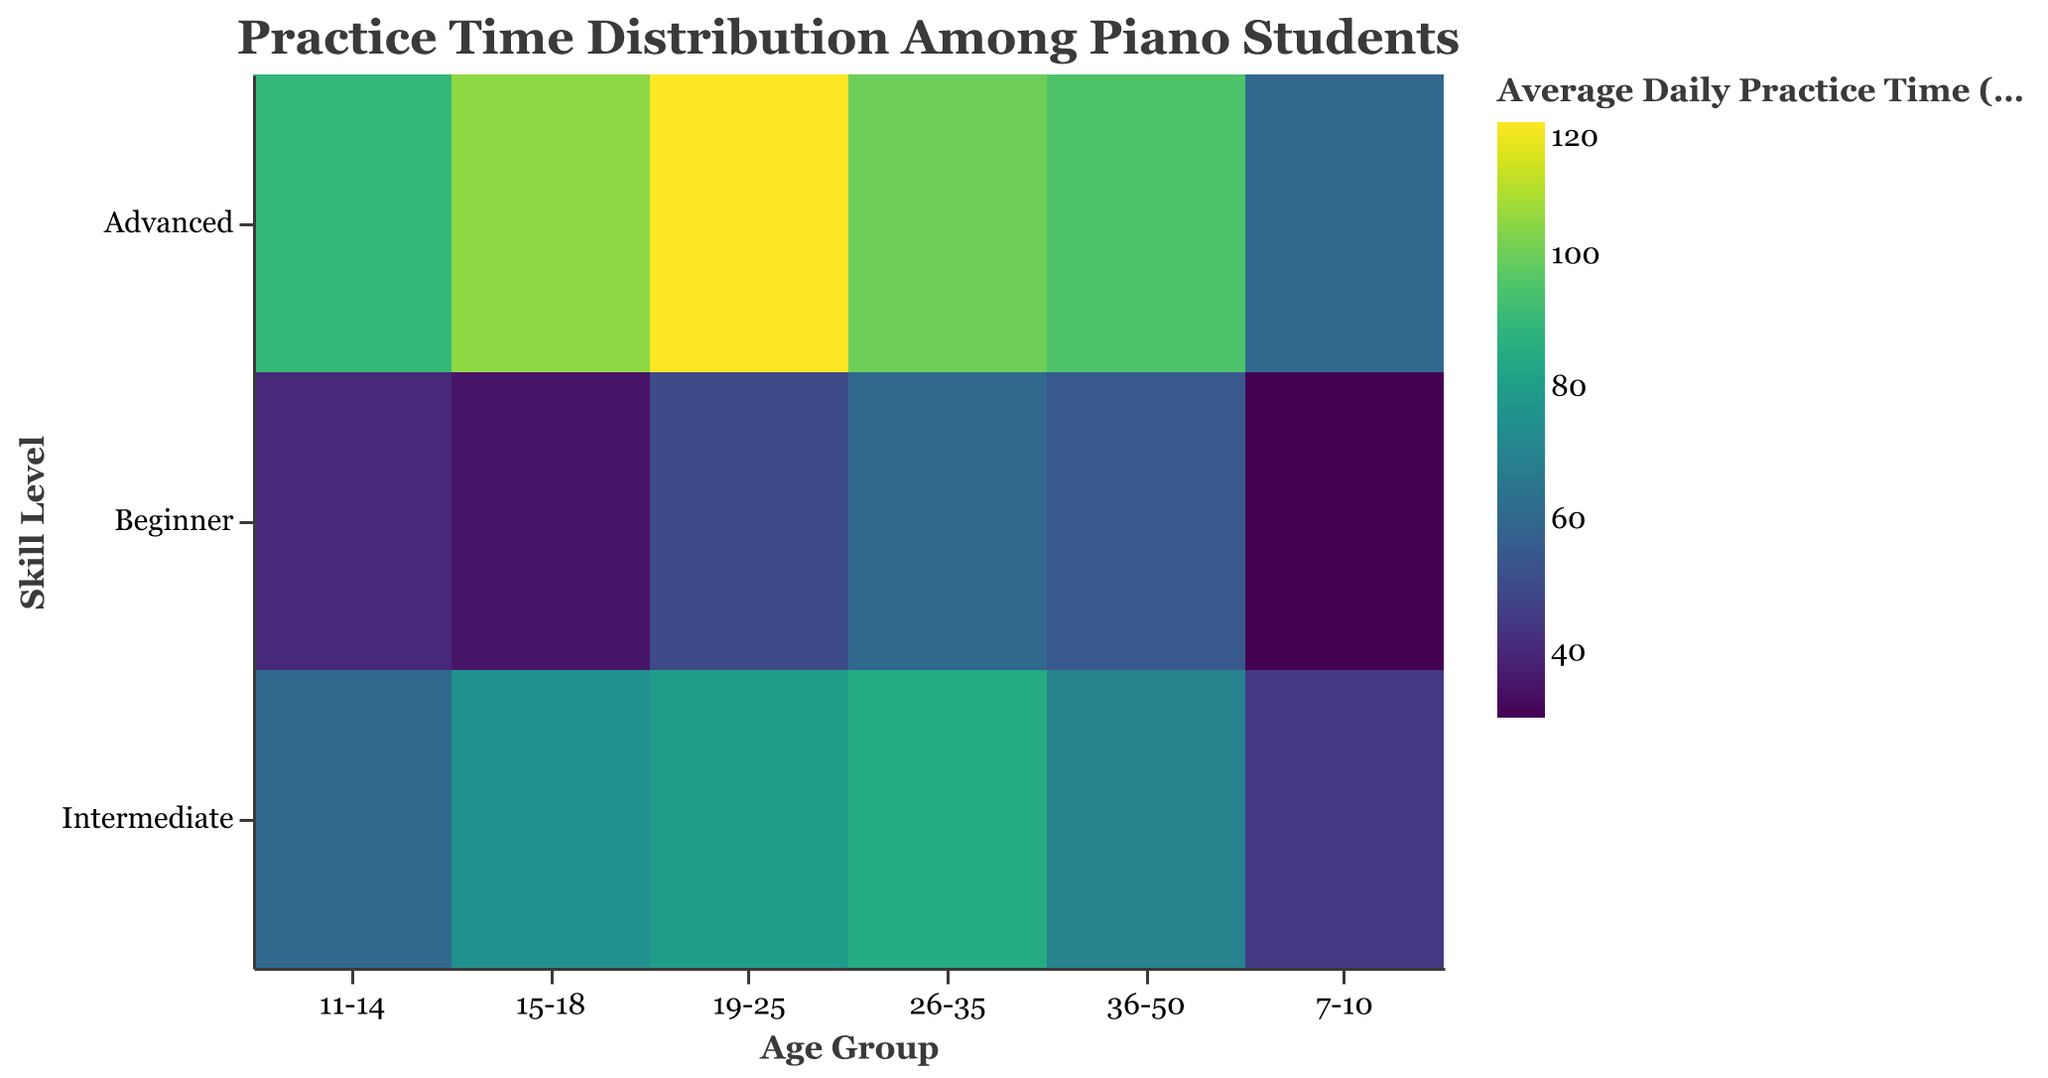What is the title of the figure? The title can be found at the top of the figure. It reads "Practice Time Distribution Among Piano Students."
Answer: Practice Time Distribution Among Piano Students What is the average daily practice time for 15-18 year old advanced students? Locate the cell corresponding to the 15-18 age group and the advanced skill level. The value in the cell is 105 minutes.
Answer: 105 minutes Which age group has the highest average daily practice time for beginner students? Compare the average daily practice times across the "Beginner" row for each age group. The highest value is 60 minutes for the 26-35 age group.
Answer: 26-35 What is the difference in average daily practice time between intermediate and advanced students aged 11-14? Locate the cells for 11-14 year old intermediate (60 minutes) and advanced (90 minutes) students. Subtract the intermediate value from the advanced value: 90 - 60 = 30 minutes.
Answer: 30 minutes Which age group has the smallest range of average daily practice times across all skill levels? Calculate the range (maximum minus minimum values) for each age group and compare them. For 36-50: 95-55=40, 26-35: 100-60=40, 19-25: 120-50=70, 15-18: 105-35=70, 11-14: 90-40=50, 7-10: 60-30=30. The smallest range is 30 for the 7-10 age group.
Answer: 7-10 What is the overall trend in practice time as skill level increases within each age group? Examine the pattern of values in each age group row. For all age groups, the practice time increases as the skill level goes from Beginner to Intermediate to Advanced.
Answer: Increases How does the practice time for students aged 19-25 compare among the different skill levels? Locate the cells for the 19-25 age group across all skill levels. The practice times are 50 minutes for Beginner, 80 minutes for Intermediate, and 120 minutes for Advanced.
Answer: 50 minutes, 80 minutes, 120 minutes Which skill level has the most consistent average daily practice time across all age groups? Compare the practice times across different age groups within each skill level. The "Advanced" skill level shows a relatively small variation between 60 and 120 minutes, indicating consistency.
Answer: Advanced What's the highest average daily practice time recorded in the figure, and which group does it belong to? Identify the highest value in the color legend, which is 120 minutes for 19-25 year old advanced students.
Answer: 120 minutes, 19-25 Advanced 